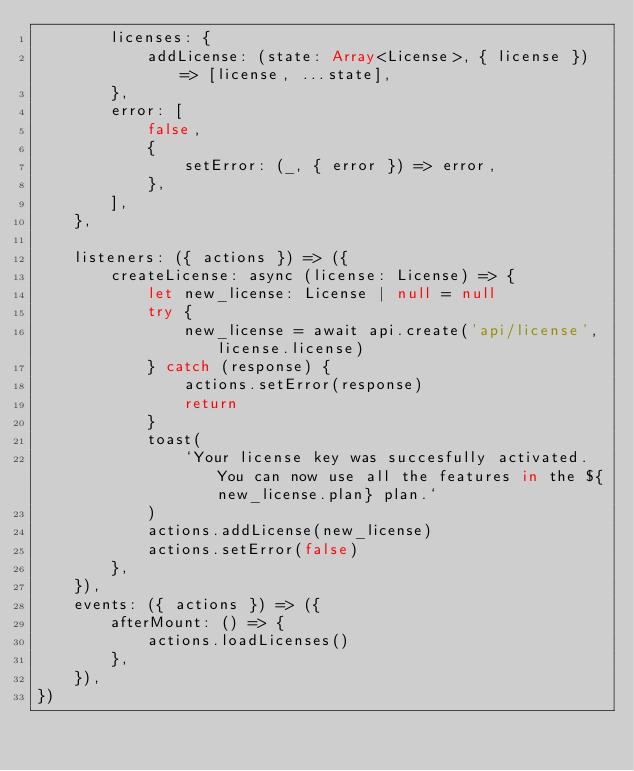<code> <loc_0><loc_0><loc_500><loc_500><_TypeScript_>        licenses: {
            addLicense: (state: Array<License>, { license }) => [license, ...state],
        },
        error: [
            false,
            {
                setError: (_, { error }) => error,
            },
        ],
    },

    listeners: ({ actions }) => ({
        createLicense: async (license: License) => {
            let new_license: License | null = null
            try {
                new_license = await api.create('api/license', license.license)
            } catch (response) {
                actions.setError(response)
                return
            }
            toast(
                `Your license key was succesfully activated. You can now use all the features in the ${new_license.plan} plan.`
            )
            actions.addLicense(new_license)
            actions.setError(false)
        },
    }),
    events: ({ actions }) => ({
        afterMount: () => {
            actions.loadLicenses()
        },
    }),
})
</code> 